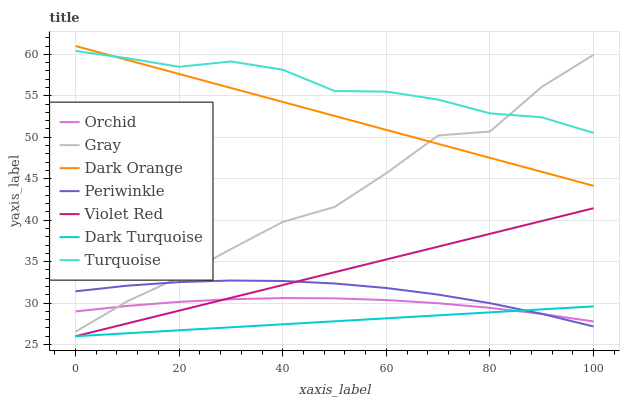Does Dark Turquoise have the minimum area under the curve?
Answer yes or no. Yes. Does Turquoise have the maximum area under the curve?
Answer yes or no. Yes. Does Violet Red have the minimum area under the curve?
Answer yes or no. No. Does Violet Red have the maximum area under the curve?
Answer yes or no. No. Is Violet Red the smoothest?
Answer yes or no. Yes. Is Gray the roughest?
Answer yes or no. Yes. Is Gray the smoothest?
Answer yes or no. No. Is Violet Red the roughest?
Answer yes or no. No. Does Violet Red have the lowest value?
Answer yes or no. Yes. Does Gray have the lowest value?
Answer yes or no. No. Does Dark Orange have the highest value?
Answer yes or no. Yes. Does Violet Red have the highest value?
Answer yes or no. No. Is Violet Red less than Dark Orange?
Answer yes or no. Yes. Is Dark Orange greater than Violet Red?
Answer yes or no. Yes. Does Violet Red intersect Orchid?
Answer yes or no. Yes. Is Violet Red less than Orchid?
Answer yes or no. No. Is Violet Red greater than Orchid?
Answer yes or no. No. Does Violet Red intersect Dark Orange?
Answer yes or no. No. 